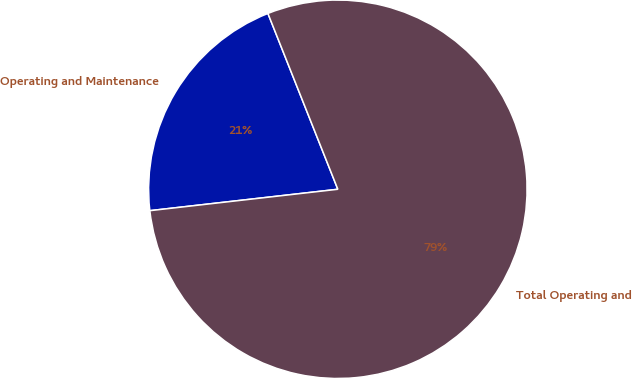Convert chart to OTSL. <chart><loc_0><loc_0><loc_500><loc_500><pie_chart><fcel>Operating and Maintenance<fcel>Total Operating and<nl><fcel>20.78%<fcel>79.22%<nl></chart> 